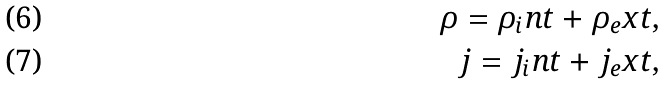Convert formula to latex. <formula><loc_0><loc_0><loc_500><loc_500>\rho = \rho _ { i } n t + \rho _ { e } x t , \\ j = j _ { i } n t + j _ { e } x t ,</formula> 